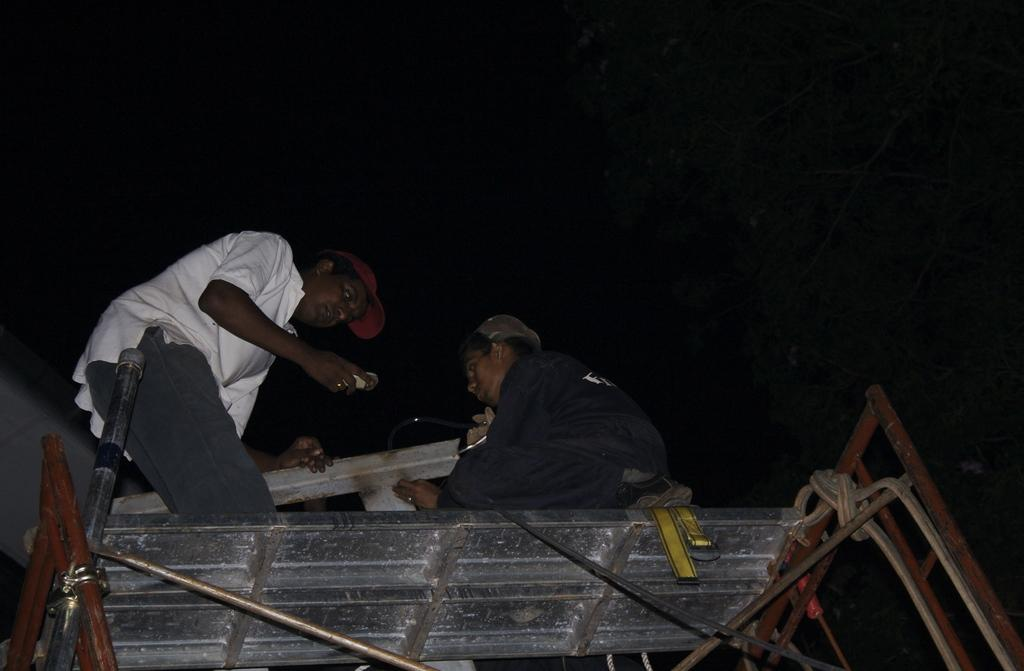How many people are in the image? There are two persons standing in the image. What are the persons standing on? The persons are standing on a stand. What can be seen in addition to the people and the stand? There are ropes visible in the image. What is the color of the background in the image? The background of the image is dark. Reasoning: Let' Let's think step by step in order to produce the conversation. We start by identifying the main subjects in the image, which are the two persons. Then, we describe what they are standing on, which is a stand. Next, we mention the presence of ropes, which adds more detail to the image. Finally, we describe the background color, which is dark. Absurd Question/Answer: What type of coal is being used to make the cups in the image? There is no coal or cups present in the image. 